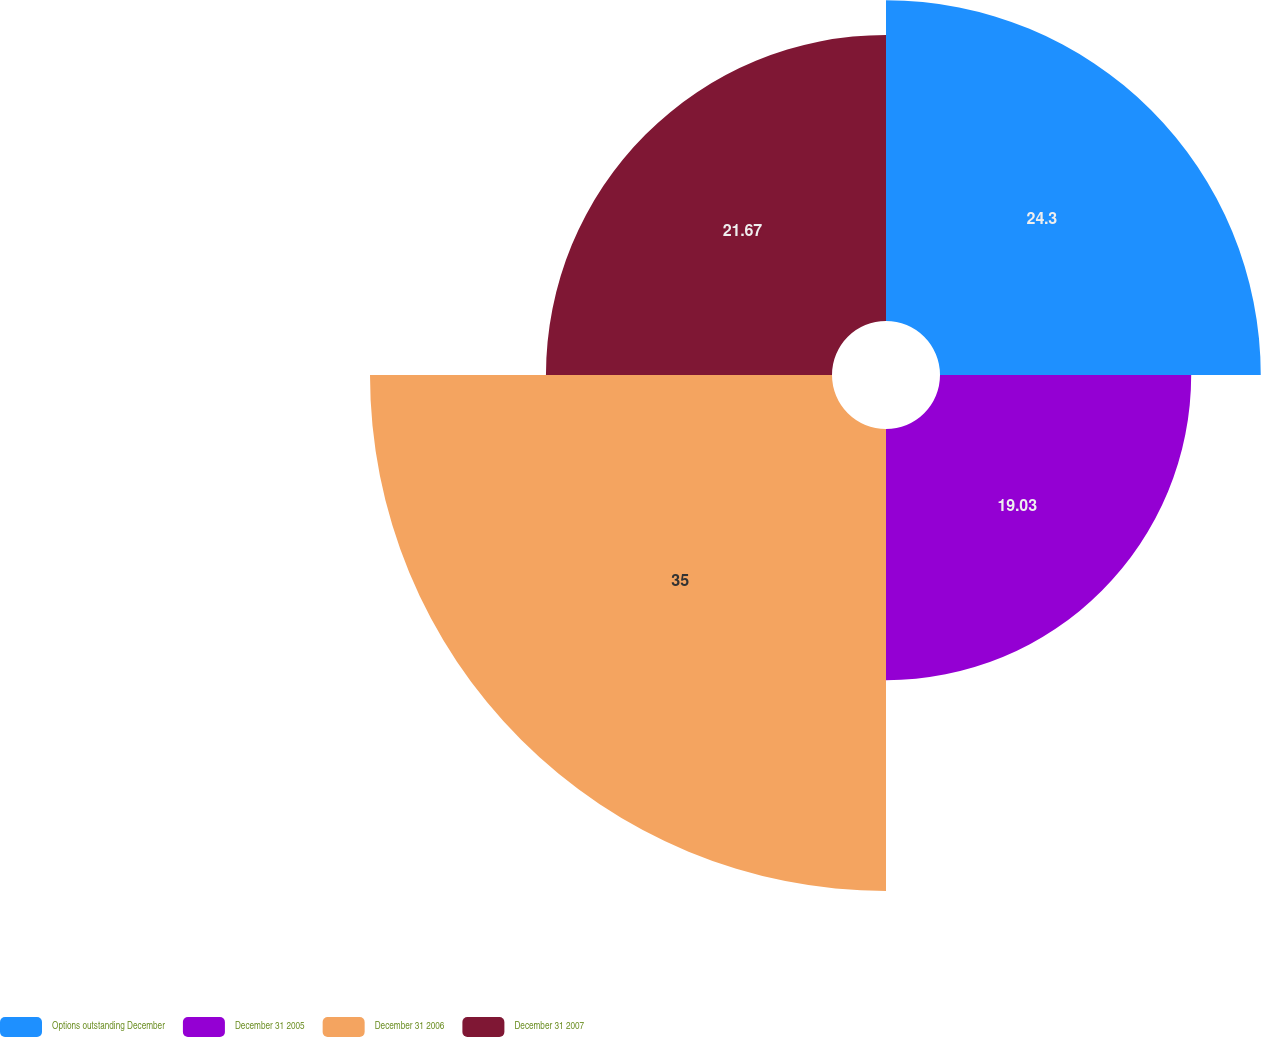Convert chart. <chart><loc_0><loc_0><loc_500><loc_500><pie_chart><fcel>Options outstanding December<fcel>December 31 2005<fcel>December 31 2006<fcel>December 31 2007<nl><fcel>24.3%<fcel>19.03%<fcel>35.0%<fcel>21.67%<nl></chart> 